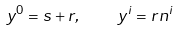Convert formula to latex. <formula><loc_0><loc_0><loc_500><loc_500>y ^ { 0 } = s + r , \quad y ^ { i } = r n ^ { i }</formula> 